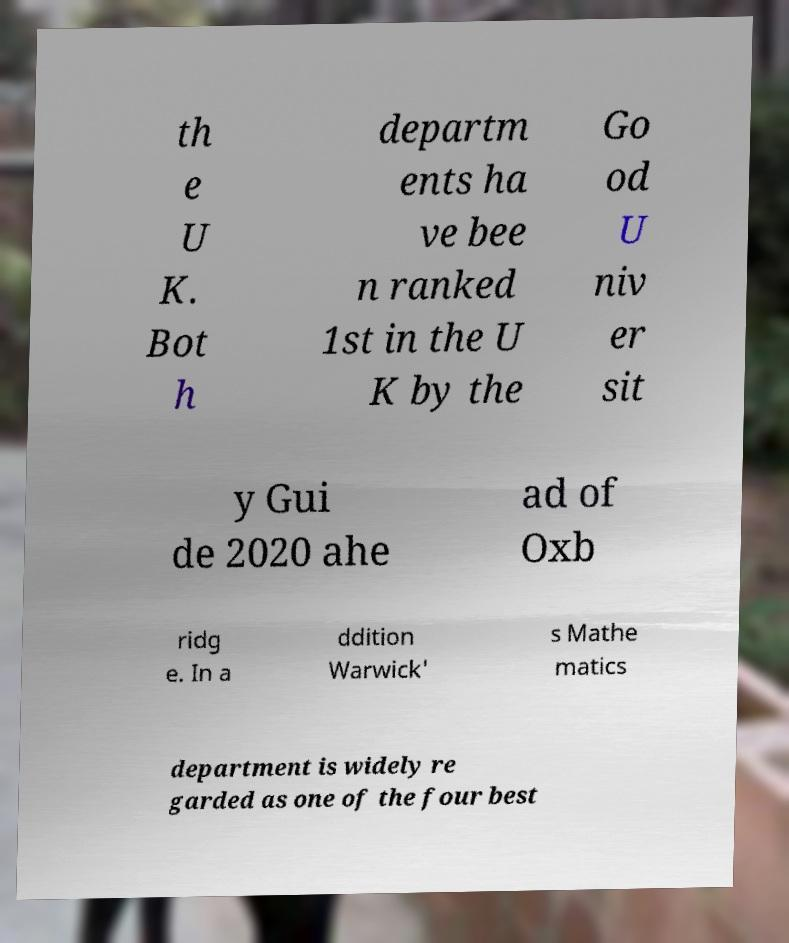Could you assist in decoding the text presented in this image and type it out clearly? th e U K. Bot h departm ents ha ve bee n ranked 1st in the U K by the Go od U niv er sit y Gui de 2020 ahe ad of Oxb ridg e. In a ddition Warwick' s Mathe matics department is widely re garded as one of the four best 